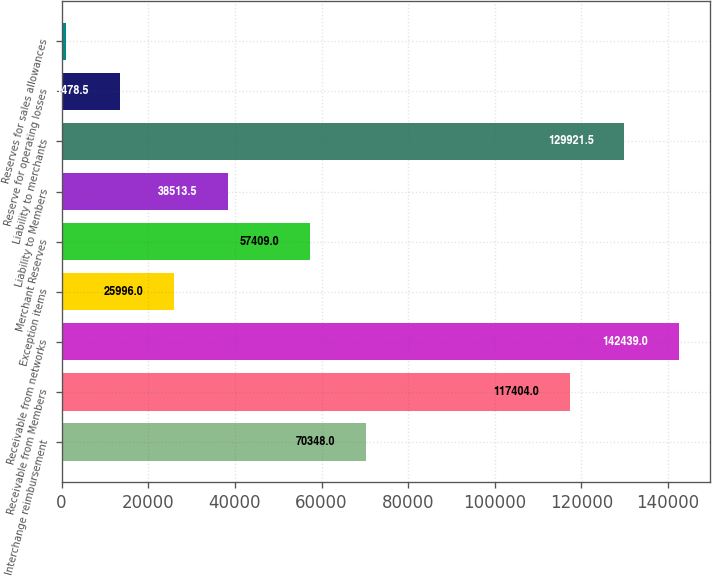Convert chart. <chart><loc_0><loc_0><loc_500><loc_500><bar_chart><fcel>Interchange reimbursement<fcel>Receivable from Members<fcel>Receivable from networks<fcel>Exception items<fcel>Merchant Reserves<fcel>Liability to Members<fcel>Liability to merchants<fcel>Reserve for operating losses<fcel>Reserves for sales allowances<nl><fcel>70348<fcel>117404<fcel>142439<fcel>25996<fcel>57409<fcel>38513.5<fcel>129922<fcel>13478.5<fcel>961<nl></chart> 